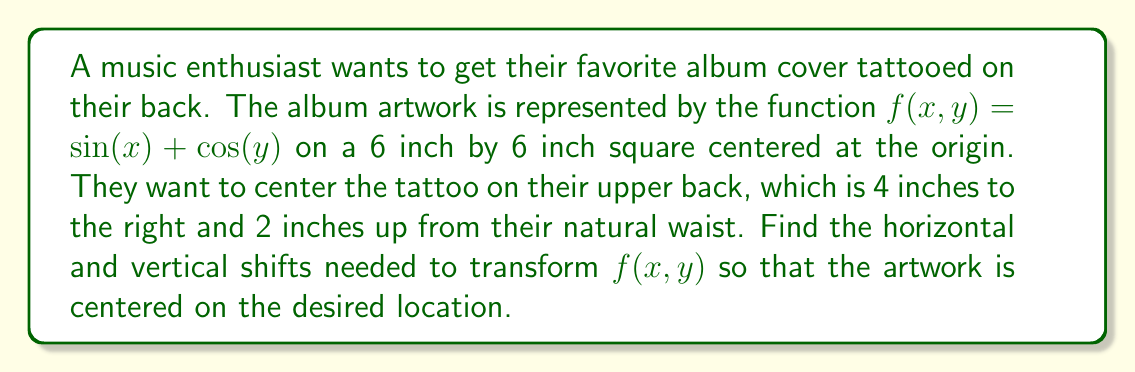Give your solution to this math problem. To center the album artwork on the desired location, we need to apply horizontal and vertical shifts to the original function $f(x,y) = \sin(x) + \cos(y)$.

Step 1: Identify the current center of the artwork.
The artwork is centered at the origin (0, 0).

Step 2: Identify the desired center location.
The desired location is 4 inches to the right and 2 inches up from the natural waist.

Step 3: Determine the horizontal shift.
To move the center 4 inches to the right, we need to subtract 4 from x:
$x \rightarrow x - 4$

Step 4: Determine the vertical shift.
To move the center 2 inches up, we need to subtract 2 from y:
$y \rightarrow y - 2$

Step 5: Apply the shifts to the original function.
The transformed function will be:
$g(x,y) = f(x-4, y-2) = \sin(x-4) + \cos(y-2)$

Therefore, the horizontal shift is 4 units right, and the vertical shift is 2 units up.
Answer: Horizontal shift: 4 units right; Vertical shift: 2 units up 